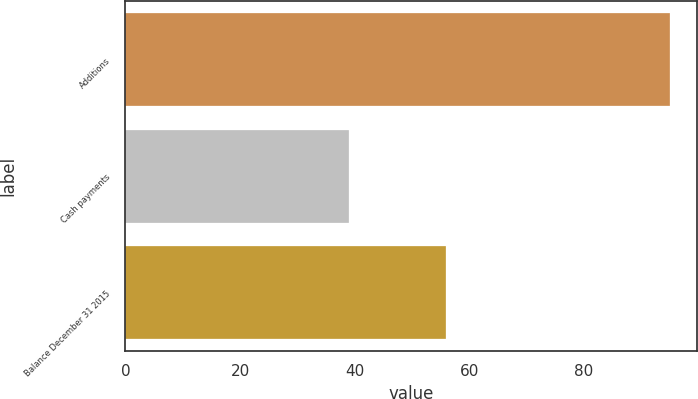Convert chart to OTSL. <chart><loc_0><loc_0><loc_500><loc_500><bar_chart><fcel>Additions<fcel>Cash payments<fcel>Balance December 31 2015<nl><fcel>95<fcel>39<fcel>56<nl></chart> 